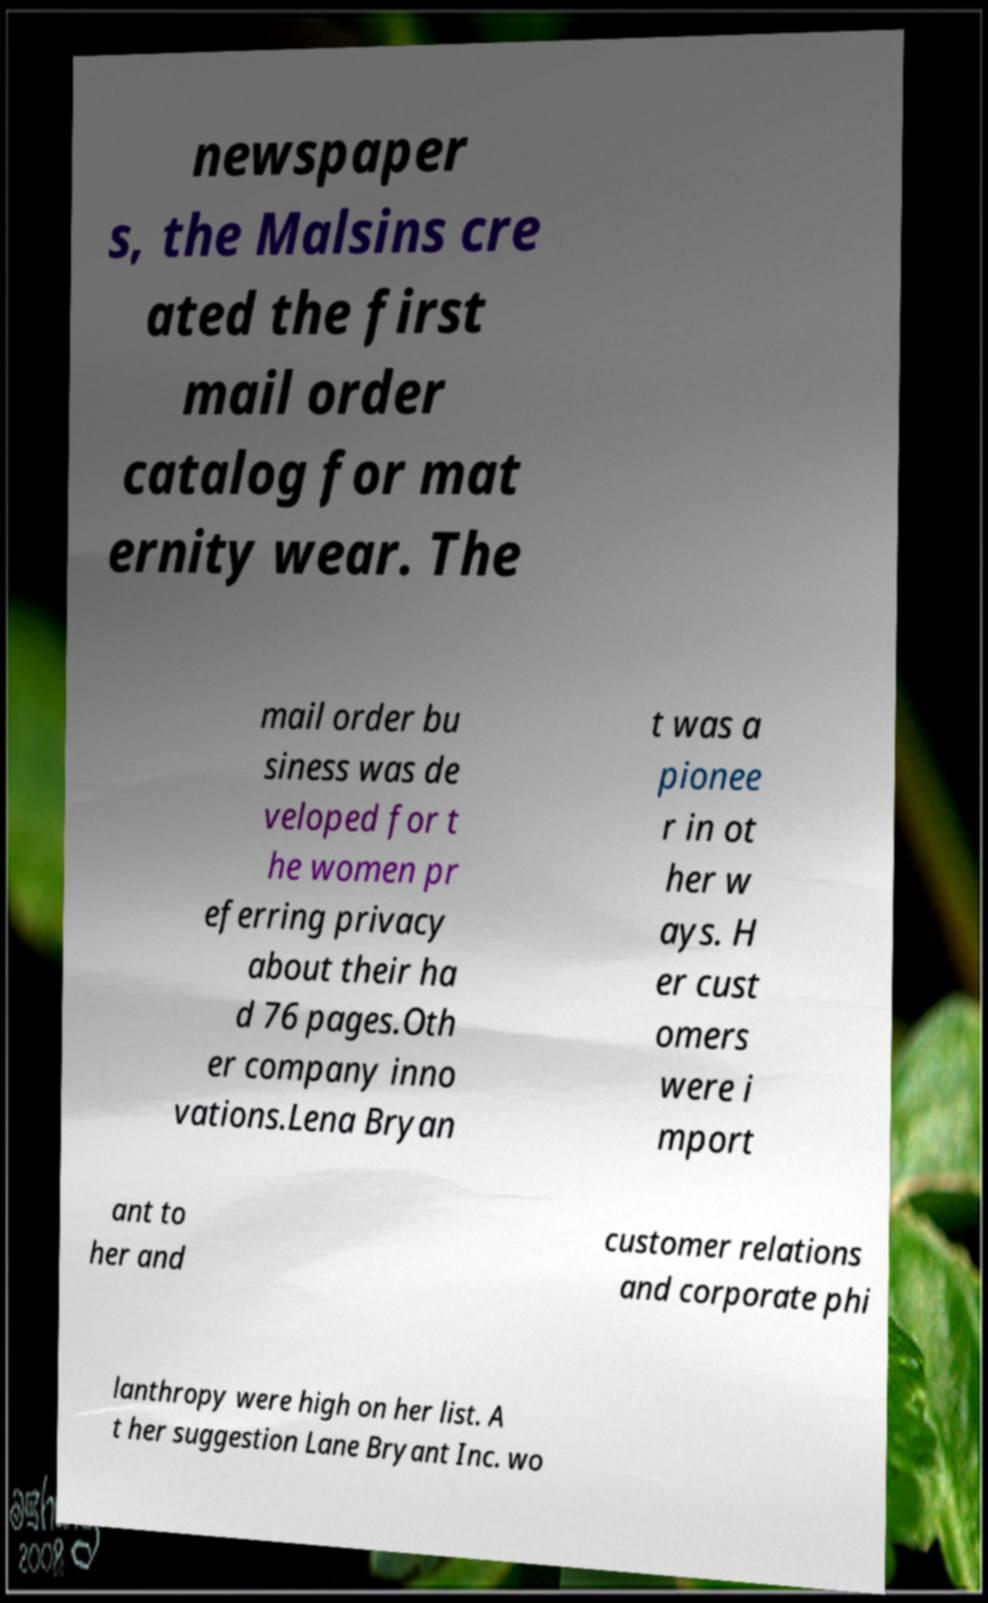There's text embedded in this image that I need extracted. Can you transcribe it verbatim? newspaper s, the Malsins cre ated the first mail order catalog for mat ernity wear. The mail order bu siness was de veloped for t he women pr eferring privacy about their ha d 76 pages.Oth er company inno vations.Lena Bryan t was a pionee r in ot her w ays. H er cust omers were i mport ant to her and customer relations and corporate phi lanthropy were high on her list. A t her suggestion Lane Bryant Inc. wo 